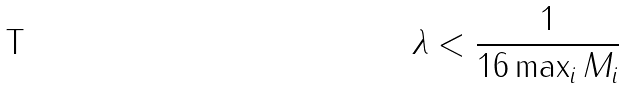Convert formula to latex. <formula><loc_0><loc_0><loc_500><loc_500>\lambda < \frac { 1 } { 1 6 \max _ { i } \| M _ { i } \| } \</formula> 